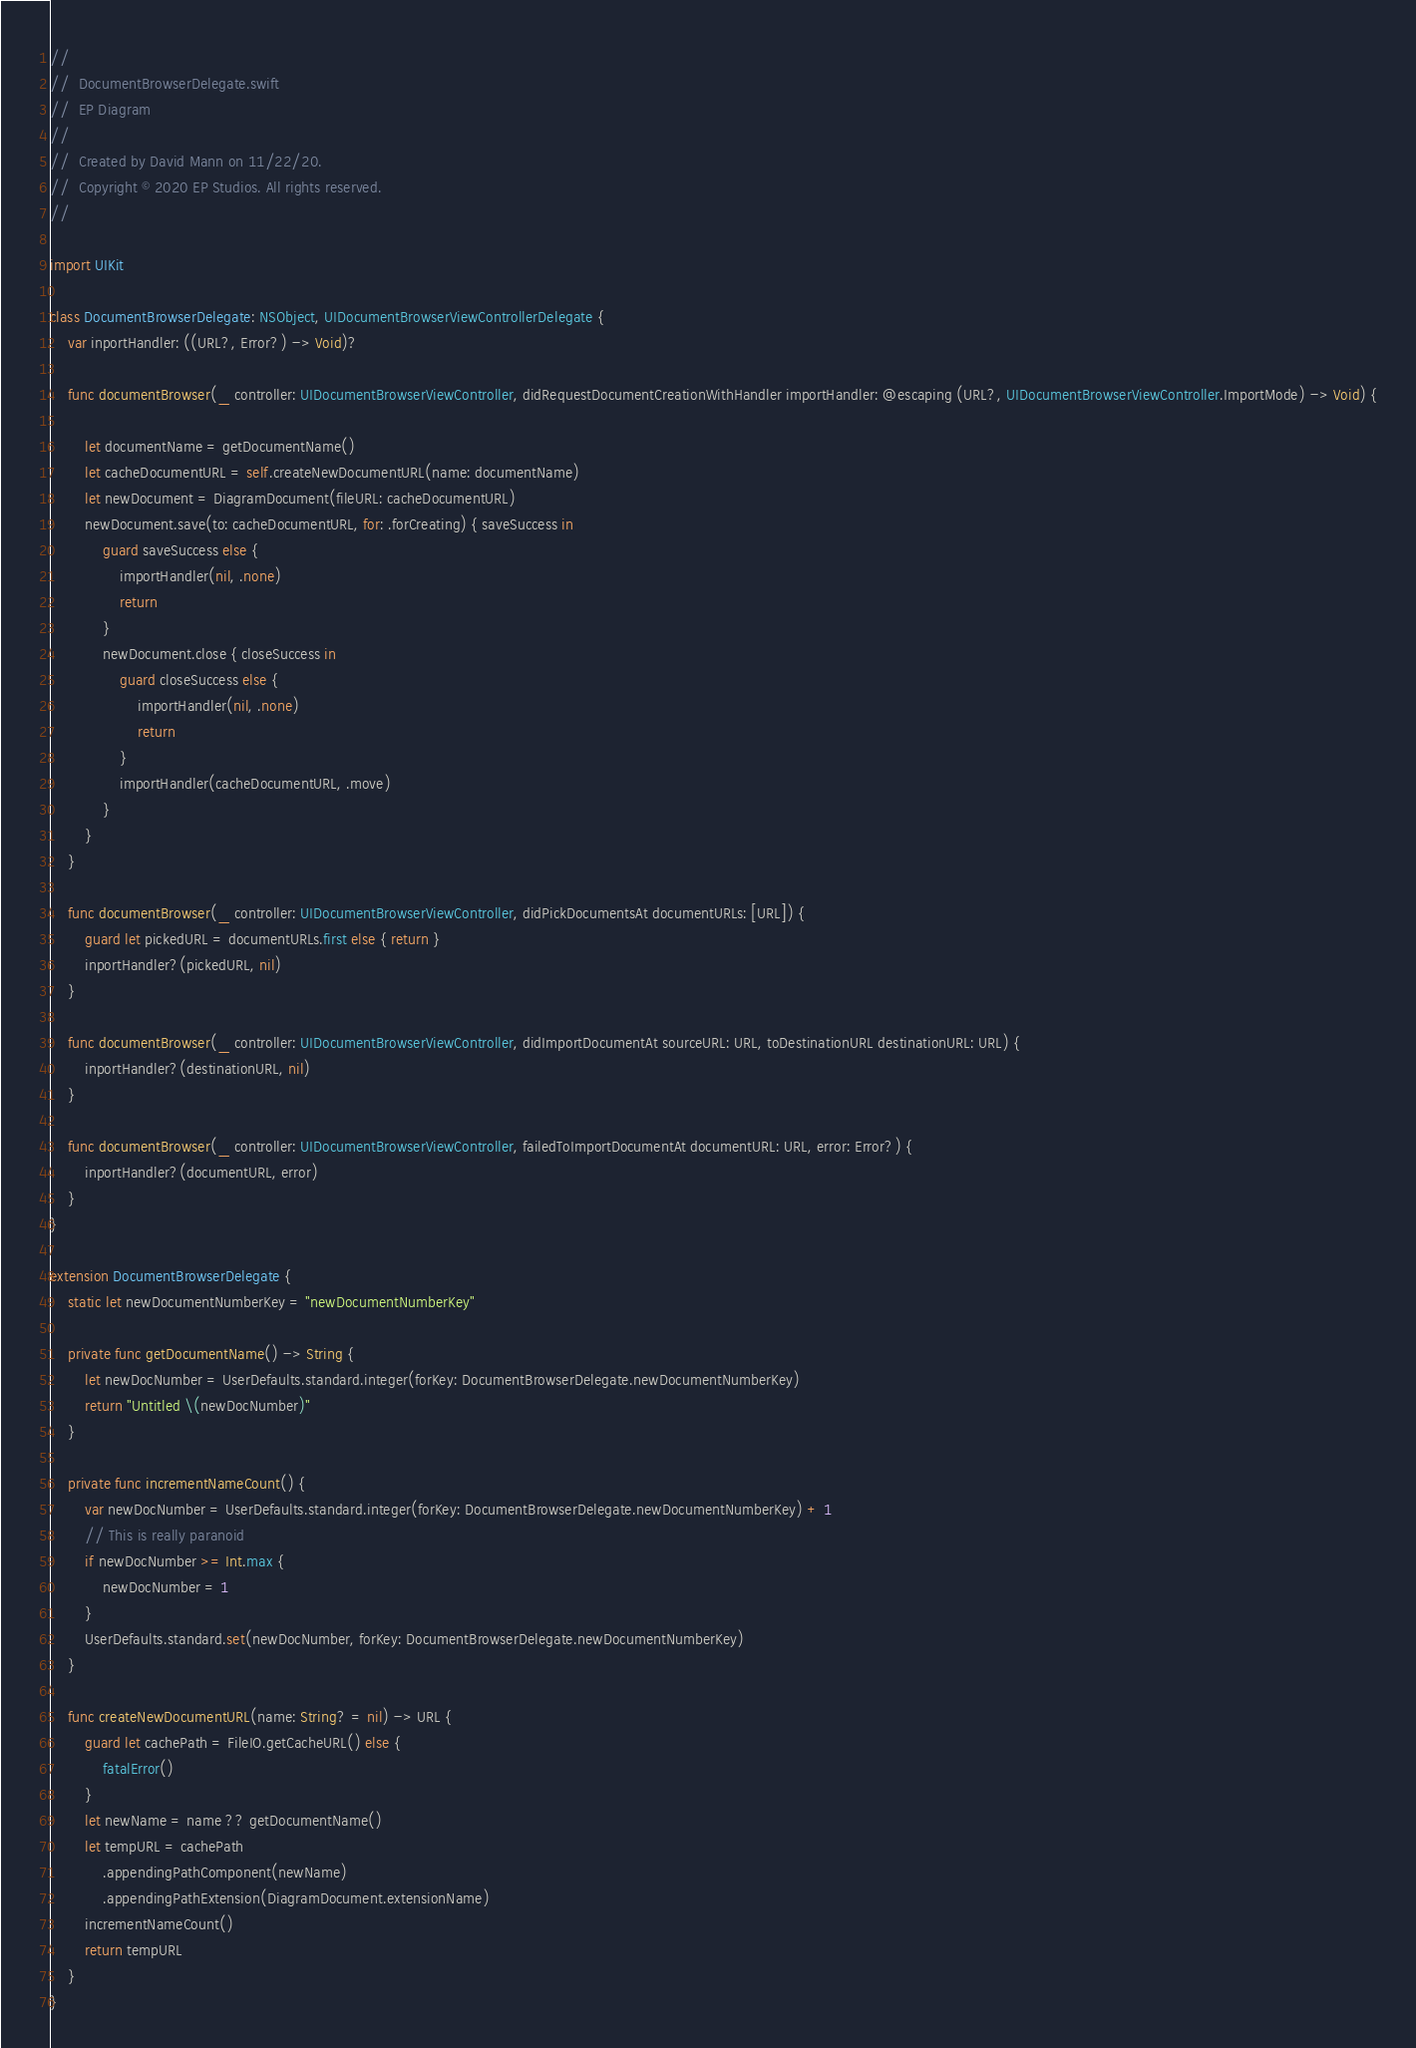<code> <loc_0><loc_0><loc_500><loc_500><_Swift_>//
//  DocumentBrowserDelegate.swift
//  EP Diagram
//
//  Created by David Mann on 11/22/20.
//  Copyright © 2020 EP Studios. All rights reserved.
//

import UIKit

class DocumentBrowserDelegate: NSObject, UIDocumentBrowserViewControllerDelegate {
    var inportHandler: ((URL?, Error?) -> Void)?

    func documentBrowser(_ controller: UIDocumentBrowserViewController, didRequestDocumentCreationWithHandler importHandler: @escaping (URL?, UIDocumentBrowserViewController.ImportMode) -> Void) {

        let documentName = getDocumentName()
        let cacheDocumentURL = self.createNewDocumentURL(name: documentName)
        let newDocument = DiagramDocument(fileURL: cacheDocumentURL)
        newDocument.save(to: cacheDocumentURL, for: .forCreating) { saveSuccess in
            guard saveSuccess else {
                importHandler(nil, .none)
                return
            }
            newDocument.close { closeSuccess in
                guard closeSuccess else {
                    importHandler(nil, .none)
                    return
                }
                importHandler(cacheDocumentURL, .move)
            }
        }
    }

    func documentBrowser(_ controller: UIDocumentBrowserViewController, didPickDocumentsAt documentURLs: [URL]) {
        guard let pickedURL = documentURLs.first else { return }
        inportHandler?(pickedURL, nil)
    }

    func documentBrowser(_ controller: UIDocumentBrowserViewController, didImportDocumentAt sourceURL: URL, toDestinationURL destinationURL: URL) {
        inportHandler?(destinationURL, nil)
    }

    func documentBrowser(_ controller: UIDocumentBrowserViewController, failedToImportDocumentAt documentURL: URL, error: Error?) {
        inportHandler?(documentURL, error)
    }
}

extension DocumentBrowserDelegate {
    static let newDocumentNumberKey = "newDocumentNumberKey"

    private func getDocumentName() -> String {
        let newDocNumber = UserDefaults.standard.integer(forKey: DocumentBrowserDelegate.newDocumentNumberKey)
        return "Untitled \(newDocNumber)"
    }

    private func incrementNameCount() {
        var newDocNumber = UserDefaults.standard.integer(forKey: DocumentBrowserDelegate.newDocumentNumberKey) + 1
        // This is really paranoid
        if newDocNumber >= Int.max {
            newDocNumber = 1
        }
        UserDefaults.standard.set(newDocNumber, forKey: DocumentBrowserDelegate.newDocumentNumberKey)
    }

    func createNewDocumentURL(name: String? = nil) -> URL {
        guard let cachePath = FileIO.getCacheURL() else {
            fatalError()
        }
        let newName = name ?? getDocumentName()
        let tempURL = cachePath
            .appendingPathComponent(newName)
            .appendingPathExtension(DiagramDocument.extensionName)
        incrementNameCount()
        return tempURL
    }
}


</code> 